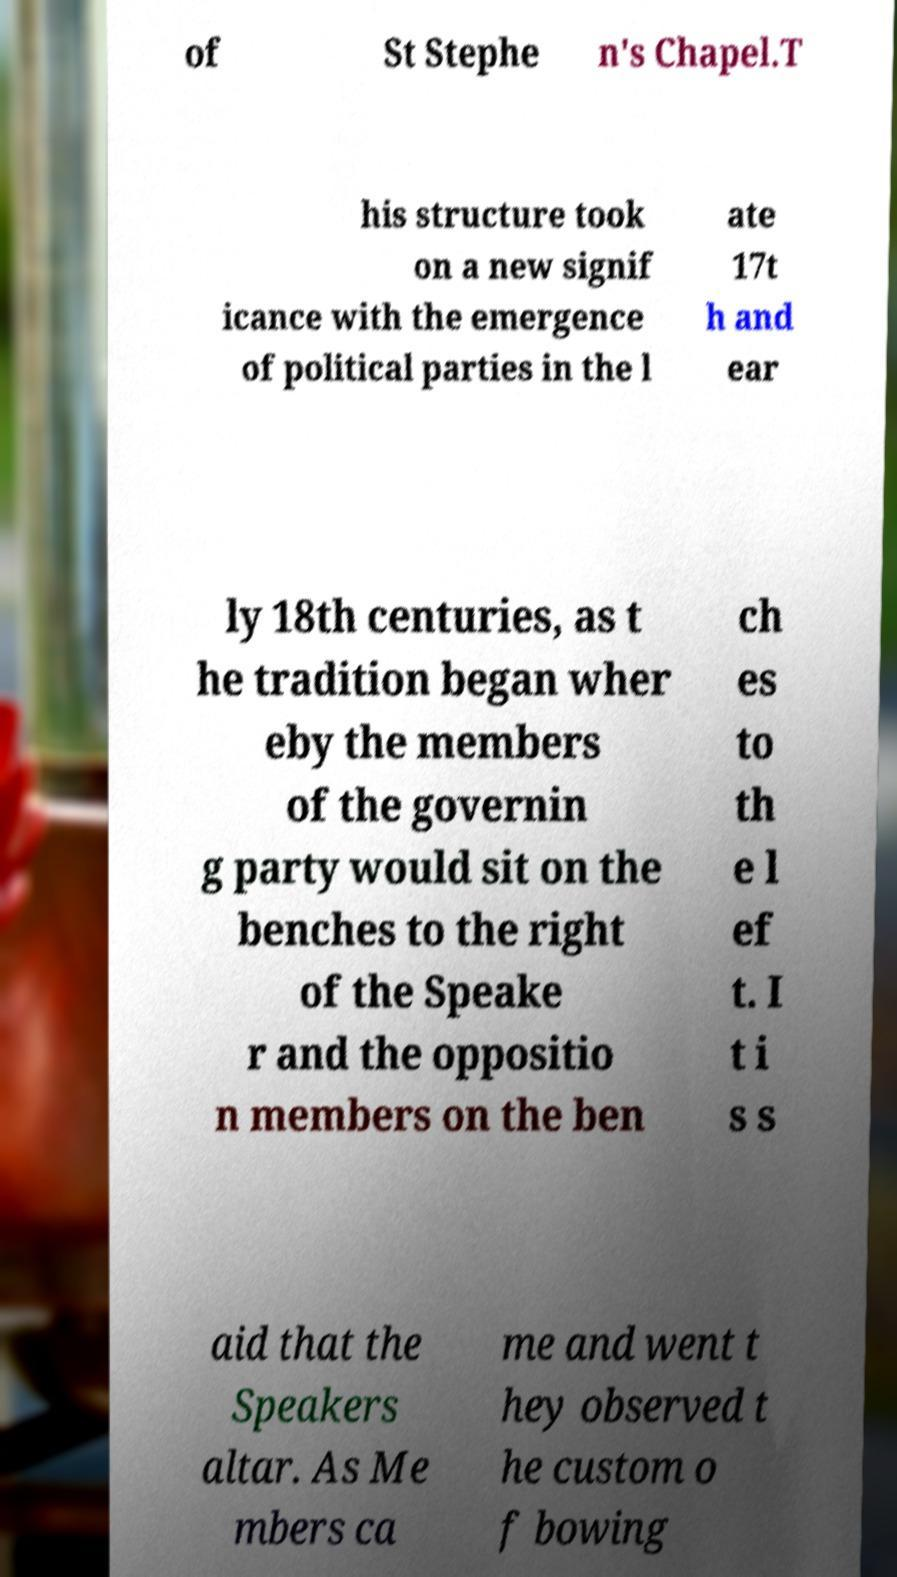For documentation purposes, I need the text within this image transcribed. Could you provide that? of St Stephe n's Chapel.T his structure took on a new signif icance with the emergence of political parties in the l ate 17t h and ear ly 18th centuries, as t he tradition began wher eby the members of the governin g party would sit on the benches to the right of the Speake r and the oppositio n members on the ben ch es to th e l ef t. I t i s s aid that the Speakers altar. As Me mbers ca me and went t hey observed t he custom o f bowing 